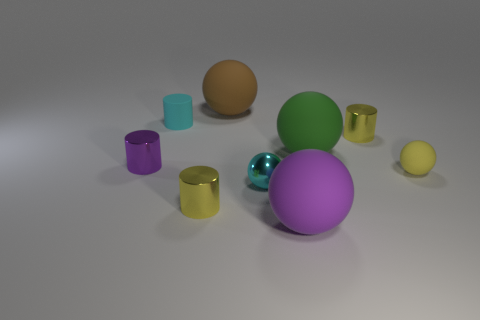Subtract all yellow spheres. How many yellow cylinders are left? 2 Subtract all yellow balls. How many balls are left? 4 Subtract all green rubber balls. How many balls are left? 4 Subtract 1 spheres. How many spheres are left? 4 Subtract all blue balls. Subtract all yellow cubes. How many balls are left? 5 Subtract all cylinders. How many objects are left? 5 Add 2 purple rubber balls. How many purple rubber balls are left? 3 Add 7 tiny cyan matte things. How many tiny cyan matte things exist? 8 Subtract 0 red cylinders. How many objects are left? 9 Subtract all large cyan objects. Subtract all big things. How many objects are left? 6 